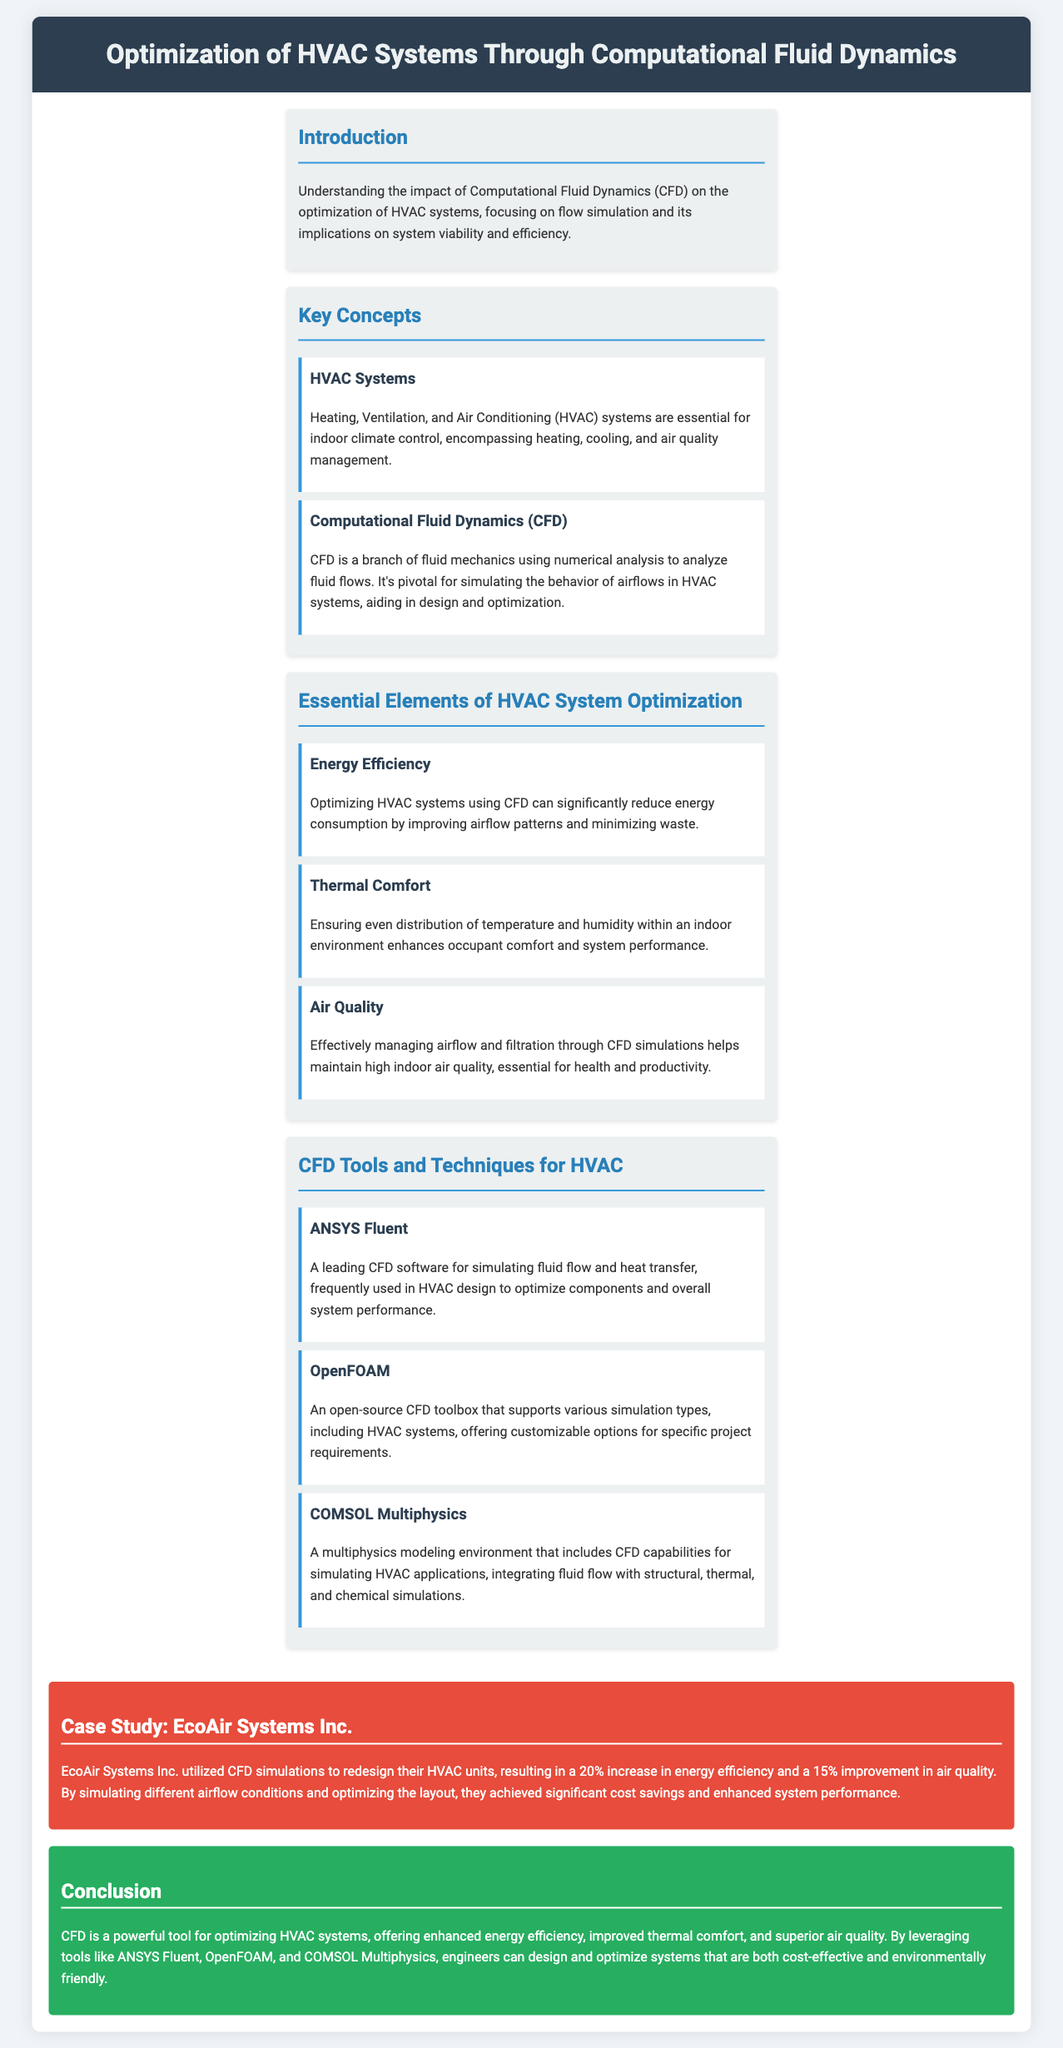What is the main focus of the document? The document focuses on the impact of Computational Fluid Dynamics (CFD) on the optimization of HVAC systems, particularly regarding flow simulation.
Answer: optimization of HVAC systems through CFD What percentage increase in energy efficiency did EcoAir Systems Inc. achieve? EcoAir Systems Inc. improved their energy efficiency by 20% as a result of CFD simulations.
Answer: 20% Which software is described as a leading CFD tool for HVAC design? ANSYS Fluent is highlighted as a leading software for simulating fluid flow and heat transfer in HVAC design.
Answer: ANSYS Fluent What are the three essential elements of HVAC system optimization mentioned? The document lists energy efficiency, thermal comfort, and air quality as essential elements of HVAC system optimization.
Answer: energy efficiency, thermal comfort, air quality What is the environmental benefit of optimizing HVAC systems through CFD? Optimizing HVAC systems through CFD leads to cost-effective and environmentally friendly designs.
Answer: environmentally friendly designs What is the case study example provided in the document? The case study focuses on EcoAir Systems Inc. and their use of CFD simulations to enhance HVAC unit design.
Answer: EcoAir Systems Inc What role does CFD play in indoor climate control? CFD aids in simulating airflow behavior, which is essential for optimizing HVAC systems for indoor climate control.
Answer: simulating airflow behavior What is the color scheme of the section headers? The section headers use a color combination of blue and dark blue with borders.
Answer: blue and dark blue How does CFD affect energy consumption in HVAC systems? CFD helps in improving airflow patterns, thereby reducing energy consumption in HVAC systems.
Answer: reducing energy consumption 